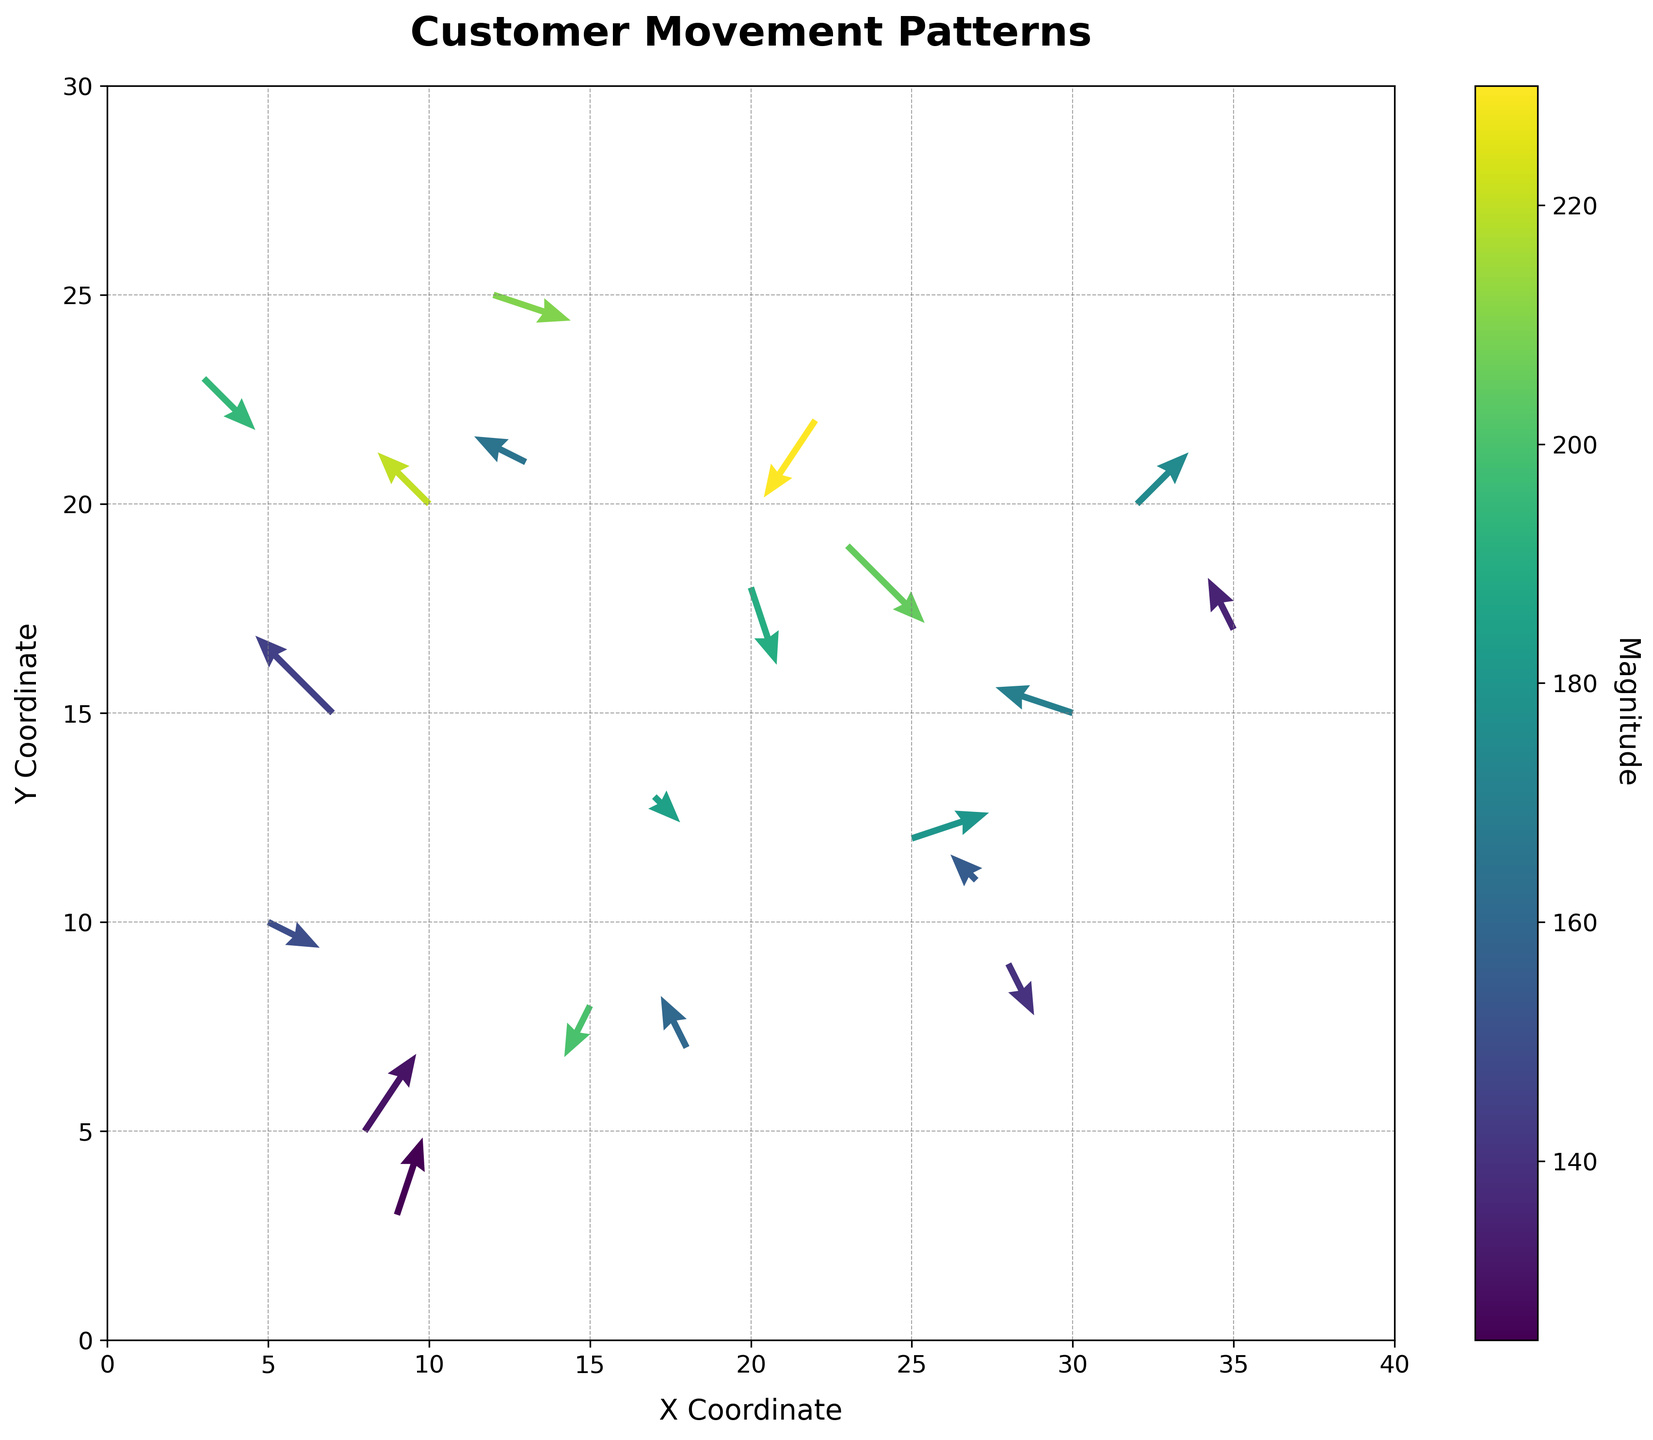How many arrows are present in the quiver plot? Count the number of arrows represented in the figure. Each arrow corresponds to a data point in the dataset.
Answer: 20 What are the minimum and maximum x-coordinates used in the plot? Look at the x-axis to identify the minimum and maximum values of the x-coordinates used for plotting arrows.
Answer: 3, 35 Where do we observe the highest magnitude value, and what is its direction? Look at the colorbar to match the highest magnitude value to its corresponding arrow in the plot, then check the direction of the arrow represented by vectors (u, v).
Answer: (22, 22), (-2, -3) Which coordinates show the highest upward movement? Check the direction vectors (u, v) and look for the largest positive v value, indicating upward movement.
Answer: (9, 3) What is the color associated with the minimum magnitude? Check the color gradient on the colorbar and determine the color used for the lowest magnitude value on the arrows.
Answer: Darkest color in the palette Identify a region where congestion might be occurring. Inspect areas with densely clustered arrows pointing towards each other or intersecting, indicating potential congestion points in the flow of customers.
Answer: Around coordinates (13, 21) Is there a general trend in the movement pattern along the x-axis? Observe the direction of the arrows along the x-axis. Determine if there's a noticeable trend in the direction customers are moving horizontally.
Answer: General leftward trend What average direction and magnitude do arrows in the top half of the plot point towards? Isolate arrows in the upper half of the y-axis (> 15). Compute the average of their direction values (u, v) and magnitudes.
Answer: Mean direction varies, around magnitude 190 Which coordinate demonstrates both high magnitude and a south-eastern direction (lower right direction)? Look for an arrow with a high magnitude color and a vector pointing to the lower right quadrants.
Answer: (10, 20), (-2, 2) Compare the direction of movement at coordinates (8, 5) and (28, 9). Which one moves more upwards? Check the v vector values at these coordinates. A higher positive v value indicates more upward movement.
Answer: (8, 5) 